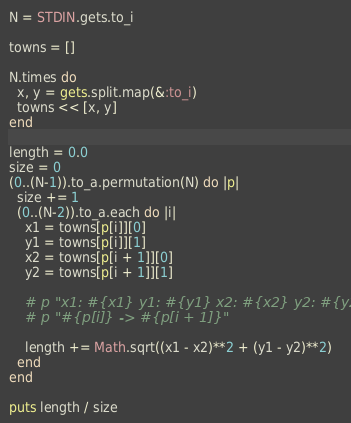Convert code to text. <code><loc_0><loc_0><loc_500><loc_500><_Ruby_>N = STDIN.gets.to_i

towns = []

N.times do
  x, y = gets.split.map(&:to_i)
  towns << [x, y]
end

length = 0.0
size = 0
(0..(N-1)).to_a.permutation(N) do |p|
  size += 1
  (0..(N-2)).to_a.each do |i|
    x1 = towns[p[i]][0]
    y1 = towns[p[i]][1]
    x2 = towns[p[i + 1]][0]
    y2 = towns[p[i + 1]][1]

    # p "x1: #{x1} y1: #{y1} x2: #{x2} y2: #{y2} "
    # p "#{p[i]} -> #{p[i + 1]}"

    length += Math.sqrt((x1 - x2)**2 + (y1 - y2)**2)
  end
end

puts length / size
</code> 